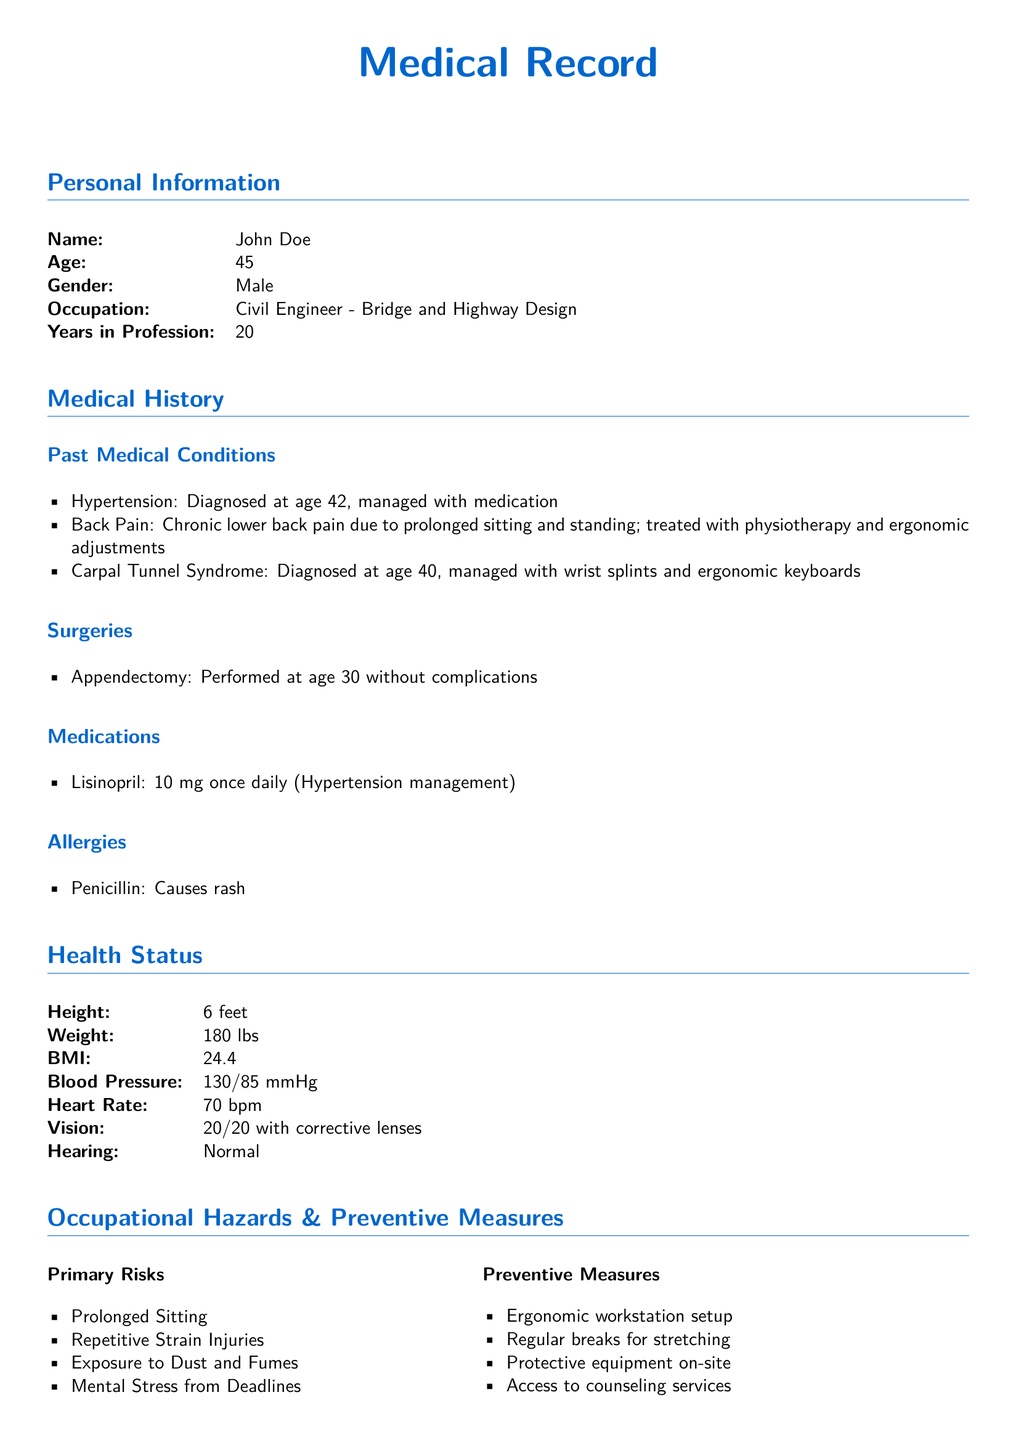What is the patient's name? The name listed in the personal information section is John Doe.
Answer: John Doe How old is the patient? The age of the patient is provided in the personal information section, which states he is 45 years old.
Answer: 45 What primary risk is associated with prolonged sitting? Prolonged sitting is linked to 'Lower back pain' as per the medical history.
Answer: Lower back pain What ergonomic practice does the patient employ for workstations? The document lists an adjustable chair as part of the ergonomic workstation setup.
Answer: Adjustable chair What is the blood pressure reading of the patient? The blood pressure is found in the health status section, which states it is 130 over 85 mmHg.
Answer: 130/85 mmHg At what age was the patient diagnosed with Carpal Tunnel Syndrome? The document states the patient was diagnosed at age 40.
Answer: 40 What preventive measure is suggested for mental stress from deadlines? The preventive measure listed for mental stress is access to counseling services.
Answer: Access to counseling services How long has the patient been a civil engineer? The document indicates he has been in the profession for 20 years.
Answer: 20 years What medication is the patient taking for hypertension? The medication listed for hypertension management is Lisinopril.
Answer: Lisinopril 